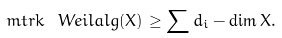<formula> <loc_0><loc_0><loc_500><loc_500>\ m t { r k } \ W e i l a l g ( X ) \geq \sum d _ { i } - \dim X .</formula> 